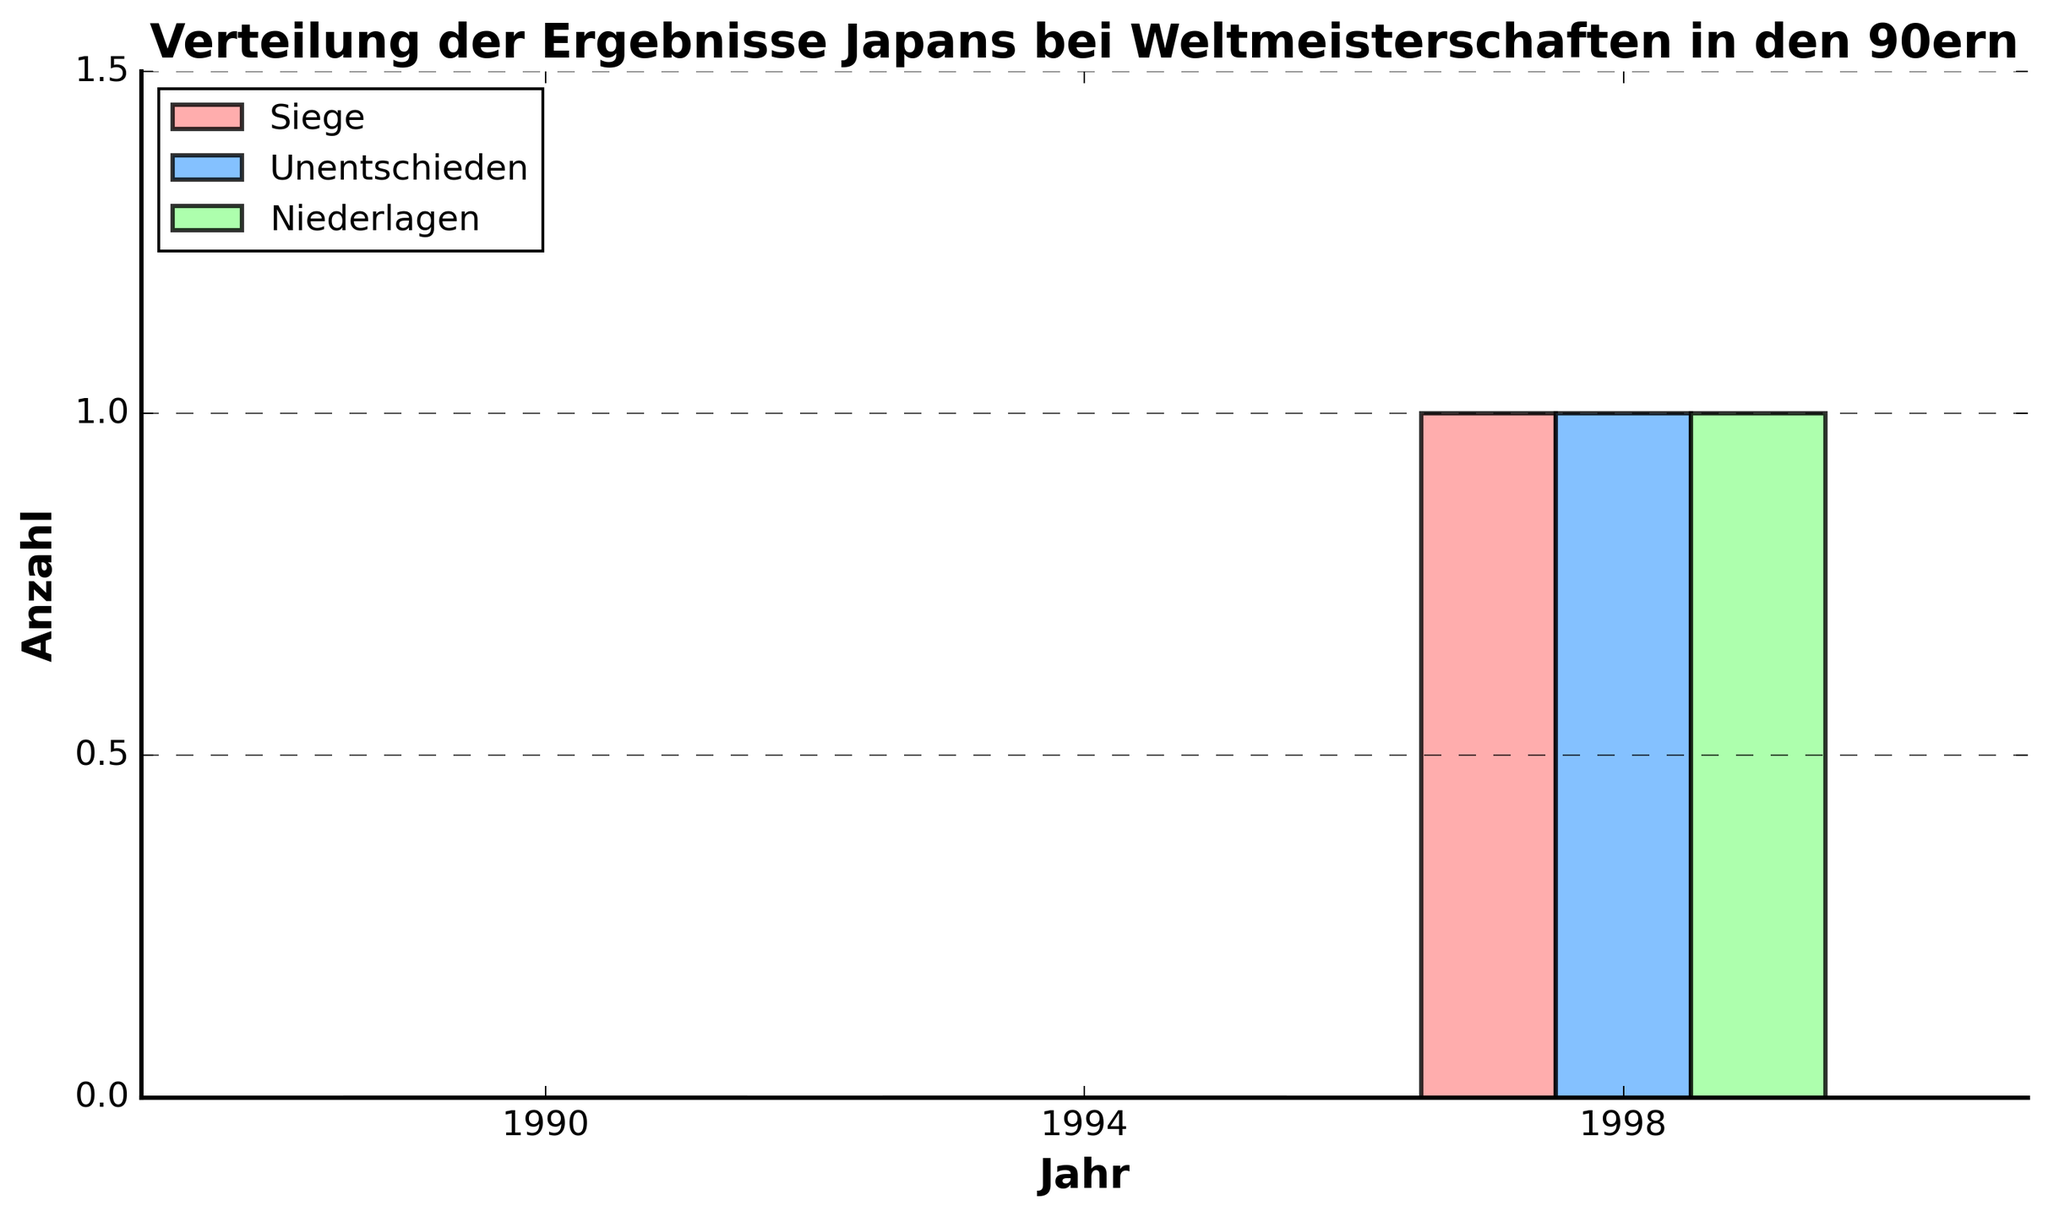Which year did Japan have its first win in the 90s? Looking at the chart, the green bar represents wins ("Siege"). The first win appears in the year 1998.
Answer: 1998 How many total matches did Japan play in the 90s World Cups? Sum all the values of wins, draws, and losses across all years: 0 wins, 0 draws, 0 losses in 1990; 0 wins, 0 draws, 0 losses in 1994; 1 win, 1 draw, 1 loss in 1998. So, the total is 0+0+0+0+0+0+1+1+1 = 3.
Answer: 3 In which year did Japan achieve the most draws in the 90s? Referring to the blue bars representing draws ("Unentschieden"), we see draws only appear in 1998.
Answer: 1998 Compare the number of losses between 1994 and 1998. In which year did Japan have more losses? The chart shows that in 1994 there are 0 losses (red bar) and in 1998 there is 1 loss. Therefore, Japan had more losses in 1998.
Answer: 1998 What is the combined total of wins, draws, and losses for Japan in 1998? For 1998, add the values for wins (1), draws (1), and losses (1). So, the combined total is 1+1+1 = 3.
Answer: 3 By how much do Japan's draws in 1998 exceed their draws in 1994? In 1994, Japan had 0 draws and in 1998, they had 1 draw. So, the difference is 1 - 0 = 1.
Answer: 1 Which category (wins, draws, or losses) has the maximum value in the year 1998? Again, we look at the values in 1998 for wins (green bar), draws (blue bar), and losses (red bar). All categories have the value 1, so there is no maximum value; all are equal.
Answer: All are equal Visually, what is the color of the bar representing Japan's wins? From the chart, the color of the bar representing wins ("Siege") is green.
Answer: Green 